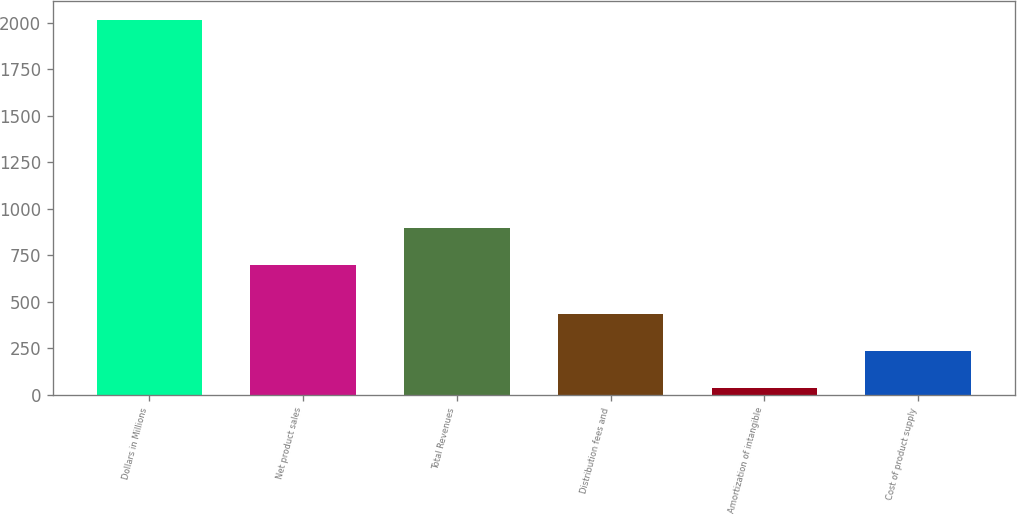Convert chart to OTSL. <chart><loc_0><loc_0><loc_500><loc_500><bar_chart><fcel>Dollars in Millions<fcel>Net product sales<fcel>Total Revenues<fcel>Distribution fees and<fcel>Amortization of intangible<fcel>Cost of product supply<nl><fcel>2013<fcel>696<fcel>893.6<fcel>432.2<fcel>37<fcel>234.6<nl></chart> 